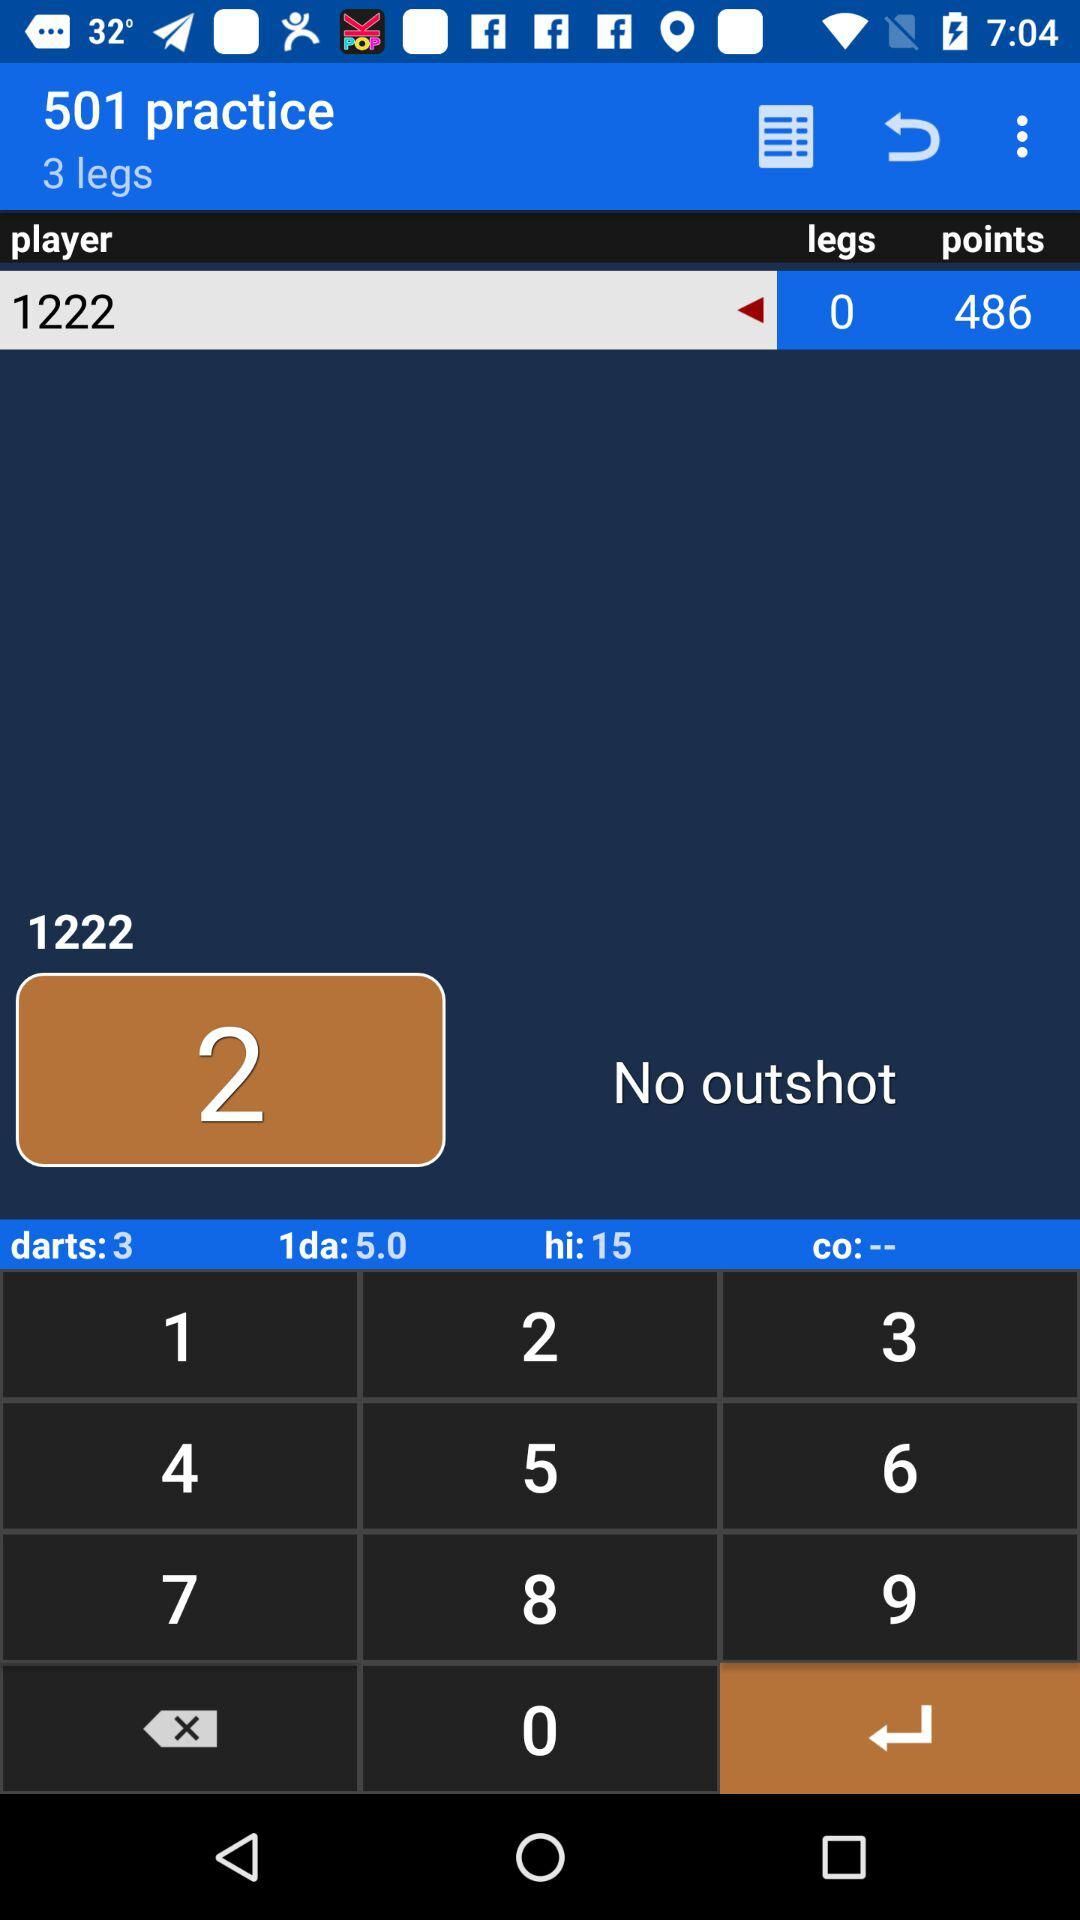How many points are in the "1da"? There are 0 points in the "1da". 